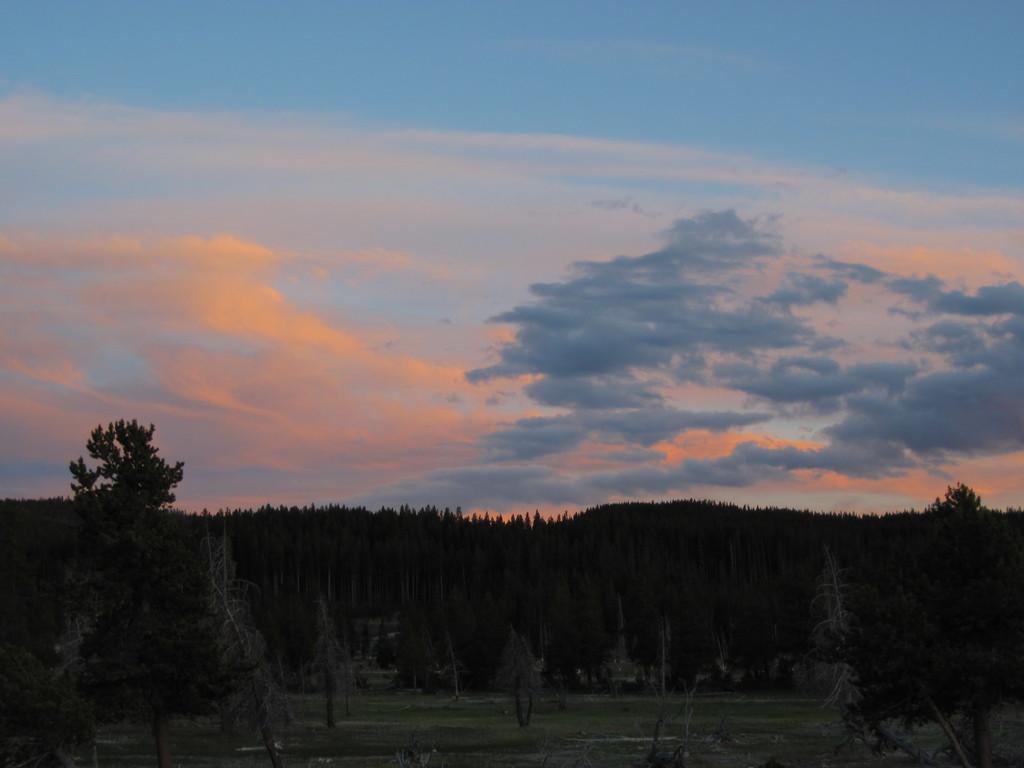Describe this image in one or two sentences. In this image we can see trees and grass are on the ground. In the background we can see clouds in the sky. 